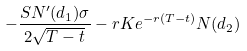Convert formula to latex. <formula><loc_0><loc_0><loc_500><loc_500>- { \frac { S N ^ { \prime } ( d _ { 1 } ) \sigma } { 2 { \sqrt { T - t } } } } - r K e ^ { - r ( T - t ) } N ( d _ { 2 } )</formula> 